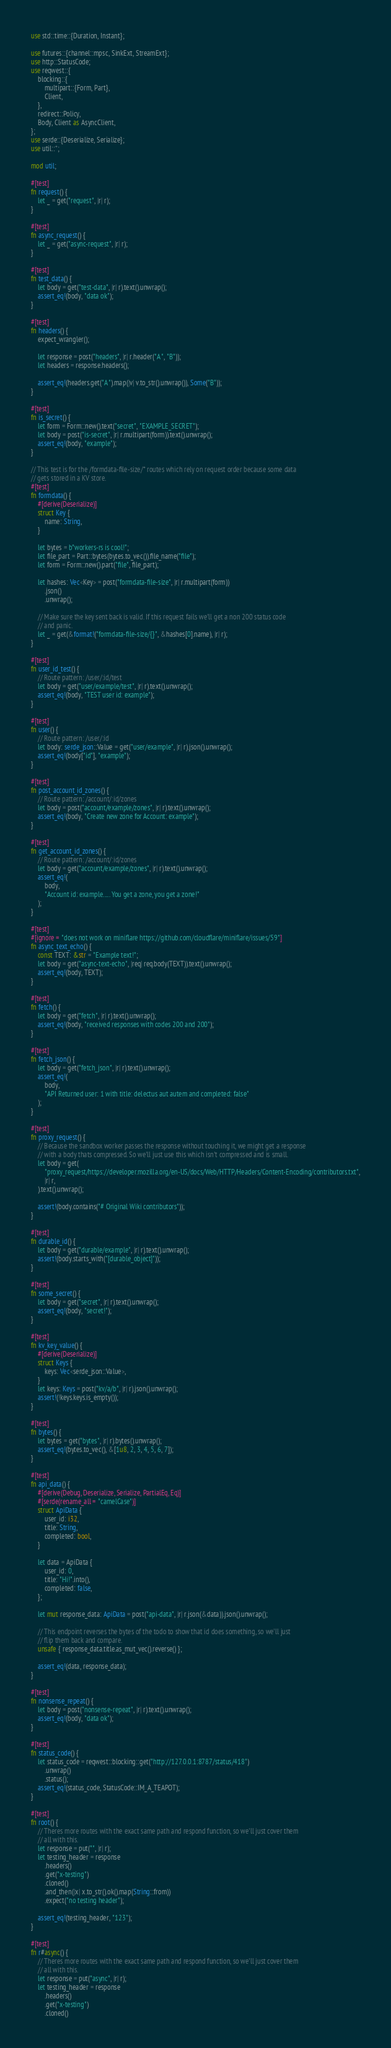<code> <loc_0><loc_0><loc_500><loc_500><_Rust_>use std::time::{Duration, Instant};

use futures::{channel::mpsc, SinkExt, StreamExt};
use http::StatusCode;
use reqwest::{
    blocking::{
        multipart::{Form, Part},
        Client,
    },
    redirect::Policy,
    Body, Client as AsyncClient,
};
use serde::{Deserialize, Serialize};
use util::*;

mod util;

#[test]
fn request() {
    let _ = get("request", |r| r);
}

#[test]
fn async_request() {
    let _ = get("async-request", |r| r);
}

#[test]
fn test_data() {
    let body = get("test-data", |r| r).text().unwrap();
    assert_eq!(body, "data ok");
}

#[test]
fn headers() {
    expect_wrangler();

    let response = post("headers", |r| r.header("A", "B"));
    let headers = response.headers();

    assert_eq!(headers.get("A").map(|v| v.to_str().unwrap()), Some("B"));
}

#[test]
fn is_secret() {
    let form = Form::new().text("secret", "EXAMPLE_SECRET");
    let body = post("is-secret", |r| r.multipart(form)).text().unwrap();
    assert_eq!(body, "example");
}

// This test is for the /formdata-file-size/* routes which rely on request order because some data
// gets stored in a KV store.
#[test]
fn formdata() {
    #[derive(Deserialize)]
    struct Key {
        name: String,
    }

    let bytes = b"workers-rs is cool!";
    let file_part = Part::bytes(bytes.to_vec()).file_name("file");
    let form = Form::new().part("file", file_part);

    let hashes: Vec<Key> = post("formdata-file-size", |r| r.multipart(form))
        .json()
        .unwrap();

    // Make sure the key sent back is valid. If this request fails we'll get a non 200 status code
    // and panic.
    let _ = get(&format!("formdata-file-size/{}", &hashes[0].name), |r| r);
}

#[test]
fn user_id_test() {
    // Route pattern: /user/:id/test
    let body = get("user/example/test", |r| r).text().unwrap();
    assert_eq!(body, "TEST user id: example");
}

#[test]
fn user() {
    // Route pattern: /user/:id
    let body: serde_json::Value = get("user/example", |r| r).json().unwrap();
    assert_eq!(body["id"], "example");
}

#[test]
fn post_account_id_zones() {
    // Route pattern: /account/:id/zones
    let body = post("account/example/zones", |r| r).text().unwrap();
    assert_eq!(body, "Create new zone for Account: example");
}

#[test]
fn get_account_id_zones() {
    // Route pattern: /account/:id/zones
    let body = get("account/example/zones", |r| r).text().unwrap();
    assert_eq!(
        body,
        "Account id: example..... You get a zone, you get a zone!"
    );
}

#[test]
#[ignore = "does not work on miniflare https://github.com/cloudflare/miniflare/issues/59"]
fn async_text_echo() {
    const TEXT: &str = "Example text!";
    let body = get("async-text-echo", |req| req.body(TEXT)).text().unwrap();
    assert_eq!(body, TEXT);
}

#[test]
fn fetch() {
    let body = get("fetch", |r| r).text().unwrap();
    assert_eq!(body, "received responses with codes 200 and 200");
}

#[test]
fn fetch_json() {
    let body = get("fetch_json", |r| r).text().unwrap();
    assert_eq!(
        body,
        "API Returned user: 1 with title: delectus aut autem and completed: false"
    );
}

#[test]
fn proxy_request() {
    // Because the sandbox worker passes the response without touching it, we might get a response
    // with a body thats compressed. So we'll just use this which isn't compressed and is small.
    let body = get(
        "proxy_request/https://developer.mozilla.org/en-US/docs/Web/HTTP/Headers/Content-Encoding/contributors.txt",
        |r| r,
    ).text().unwrap();

    assert!(body.contains("# Original Wiki contributors"));
}

#[test]
fn durable_id() {
    let body = get("durable/example", |r| r).text().unwrap();
    assert!(body.starts_with("[durable_object]"));
}

#[test]
fn some_secret() {
    let body = get("secret", |r| r).text().unwrap();
    assert_eq!(body, "secret!");
}

#[test]
fn kv_key_value() {
    #[derive(Deserialize)]
    struct Keys {
        keys: Vec<serde_json::Value>,
    }
    let keys: Keys = post("kv/a/b", |r| r).json().unwrap();
    assert!(!keys.keys.is_empty());
}

#[test]
fn bytes() {
    let bytes = get("bytes", |r| r).bytes().unwrap();
    assert_eq!(bytes.to_vec(), &[1u8, 2, 3, 4, 5, 6, 7]);
}

#[test]
fn api_data() {
    #[derive(Debug, Deserialize, Serialize, PartialEq, Eq)]
    #[serde(rename_all = "camelCase")]
    struct ApiData {
        user_id: i32,
        title: String,
        completed: bool,
    }

    let data = ApiData {
        user_id: 0,
        title: "Hi!".into(),
        completed: false,
    };

    let mut response_data: ApiData = post("api-data", |r| r.json(&data)).json().unwrap();

    // This endpoint reverses the bytes of the todo to show that id does something, so we'll just
    // flip them back and compare.
    unsafe { response_data.title.as_mut_vec().reverse() };

    assert_eq!(data, response_data);
}

#[test]
fn nonsense_repeat() {
    let body = post("nonsense-repeat", |r| r).text().unwrap();
    assert_eq!(body, "data ok");
}

#[test]
fn status_code() {
    let status_code = reqwest::blocking::get("http://127.0.0.1:8787/status/418")
        .unwrap()
        .status();
    assert_eq!(status_code, StatusCode::IM_A_TEAPOT);
}

#[test]
fn root() {
    // Theres more routes with the exact same path and respond function, so we'll just cover them
    // all with this.
    let response = put("", |r| r);
    let testing_header = response
        .headers()
        .get("x-testing")
        .cloned()
        .and_then(|x| x.to_str().ok().map(String::from))
        .expect("no testing header");

    assert_eq!(testing_header, "123");
}

#[test]
fn r#async() {
    // Theres more routes with the exact same path and respond function, so we'll just cover them
    // all with this.
    let response = put("async", |r| r);
    let testing_header = response
        .headers()
        .get("x-testing")
        .cloned()</code> 